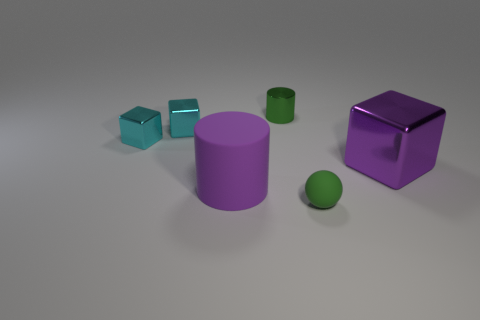Can you describe the lighting in the scene and how it affects the appearance of the objects? The image features a soft overhead lighting that casts subtle shadows below each object, giving the scene a calm and evenly lit appearance. The gentle lighting contributes to the clarity of the objects' colors and allows us to distinctly observe their matte surfaces without any harsh reflections. 